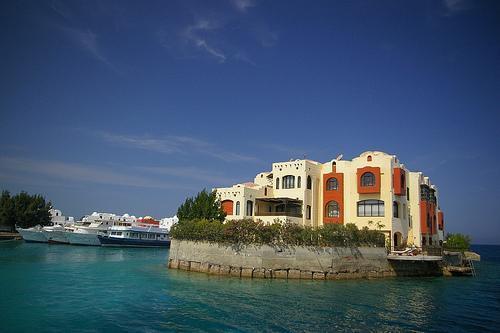How many other table and chair sets are there?
Give a very brief answer. 0. 